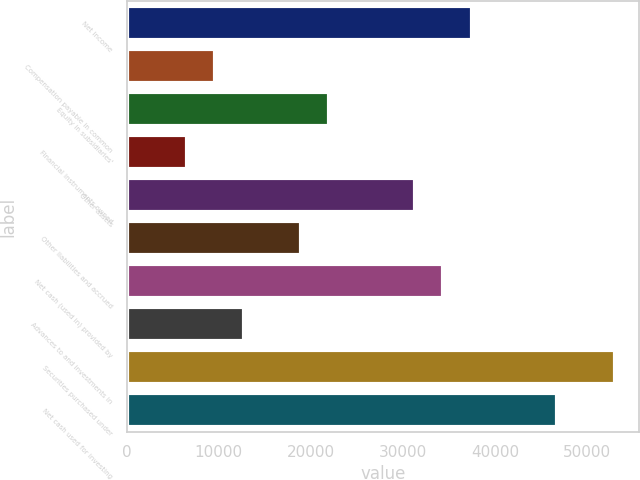Convert chart to OTSL. <chart><loc_0><loc_0><loc_500><loc_500><bar_chart><fcel>Net income<fcel>Compensation payable in common<fcel>Equity in subsidiaries'<fcel>Financial instruments owned<fcel>Other assets<fcel>Other liabilities and accrued<fcel>Net cash (used in) provided by<fcel>Advances to and investments in<fcel>Securities purchased under<fcel>Net cash used for investing<nl><fcel>37499.4<fcel>9620.1<fcel>22010.9<fcel>6522.4<fcel>31304<fcel>18913.2<fcel>34401.7<fcel>12717.8<fcel>52987.9<fcel>46792.5<nl></chart> 